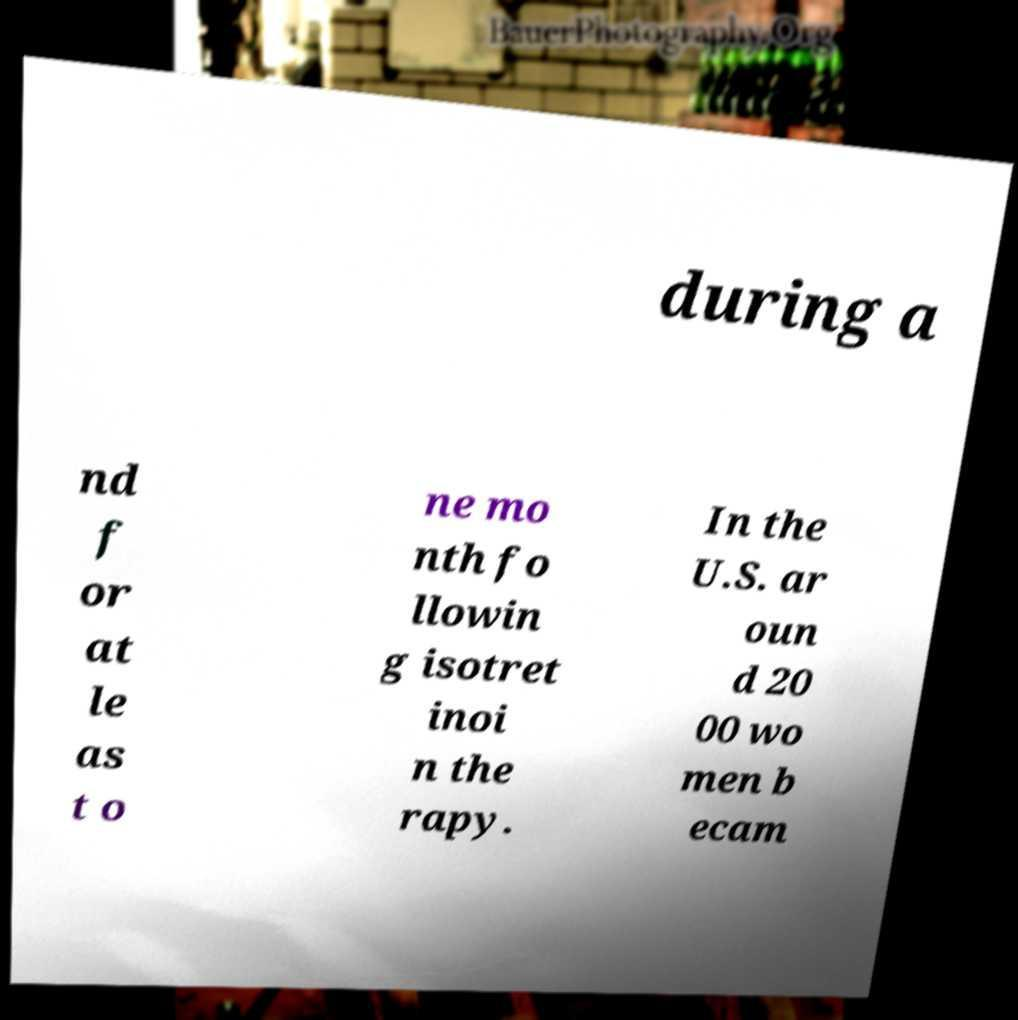Please identify and transcribe the text found in this image. during a nd f or at le as t o ne mo nth fo llowin g isotret inoi n the rapy. In the U.S. ar oun d 20 00 wo men b ecam 